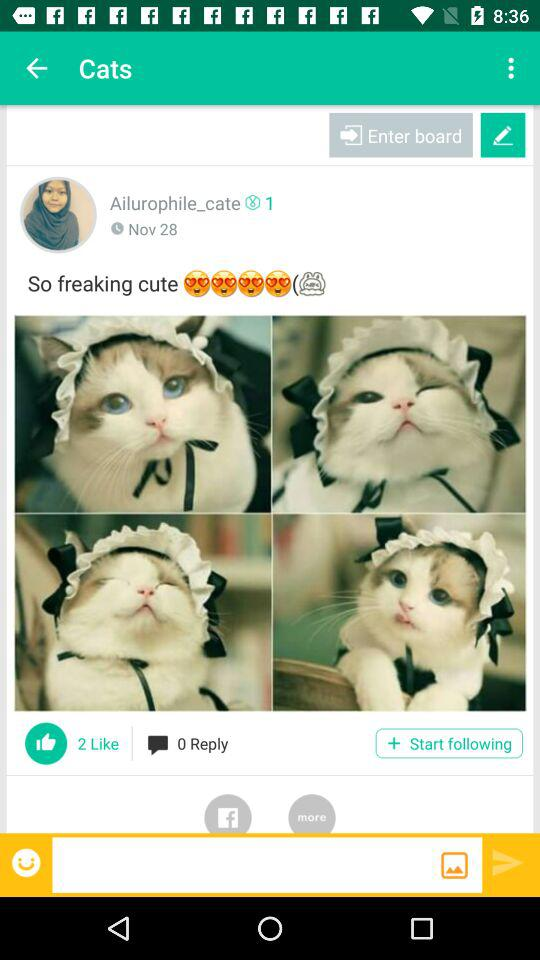How many more likes does the post have than replies?
Answer the question using a single word or phrase. 2 